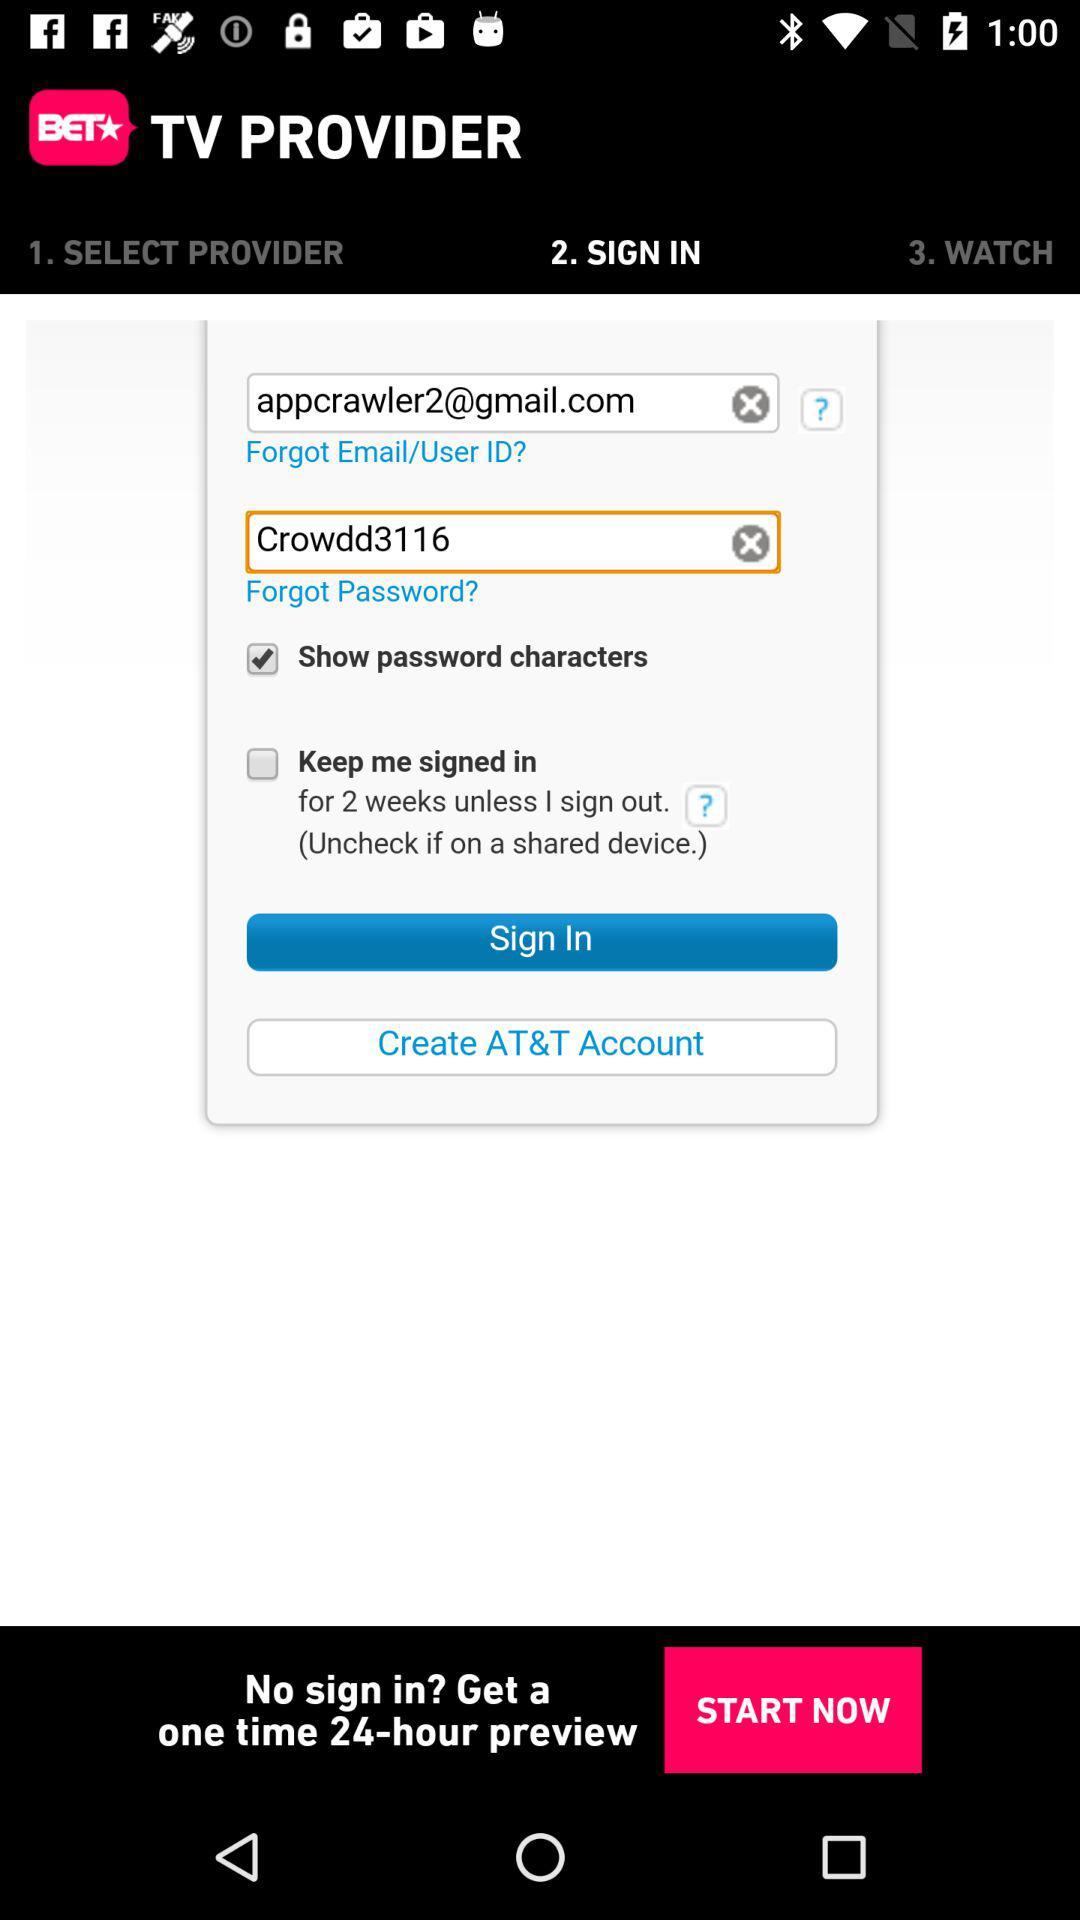What is the email address? The email address is appcrawler2@gmail.com. 